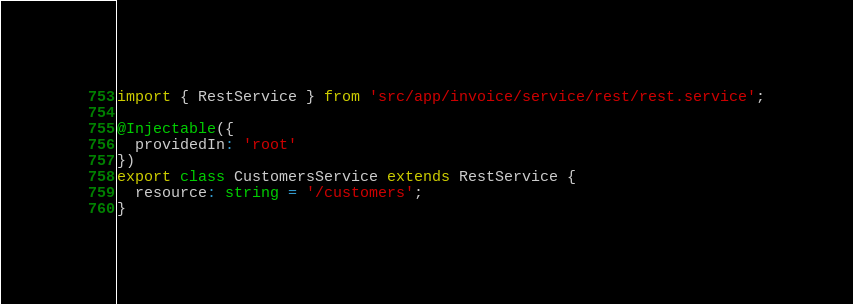Convert code to text. <code><loc_0><loc_0><loc_500><loc_500><_TypeScript_>import { RestService } from 'src/app/invoice/service/rest/rest.service';

@Injectable({
  providedIn: 'root'
})
export class CustomersService extends RestService {
  resource: string = '/customers';
}
</code> 